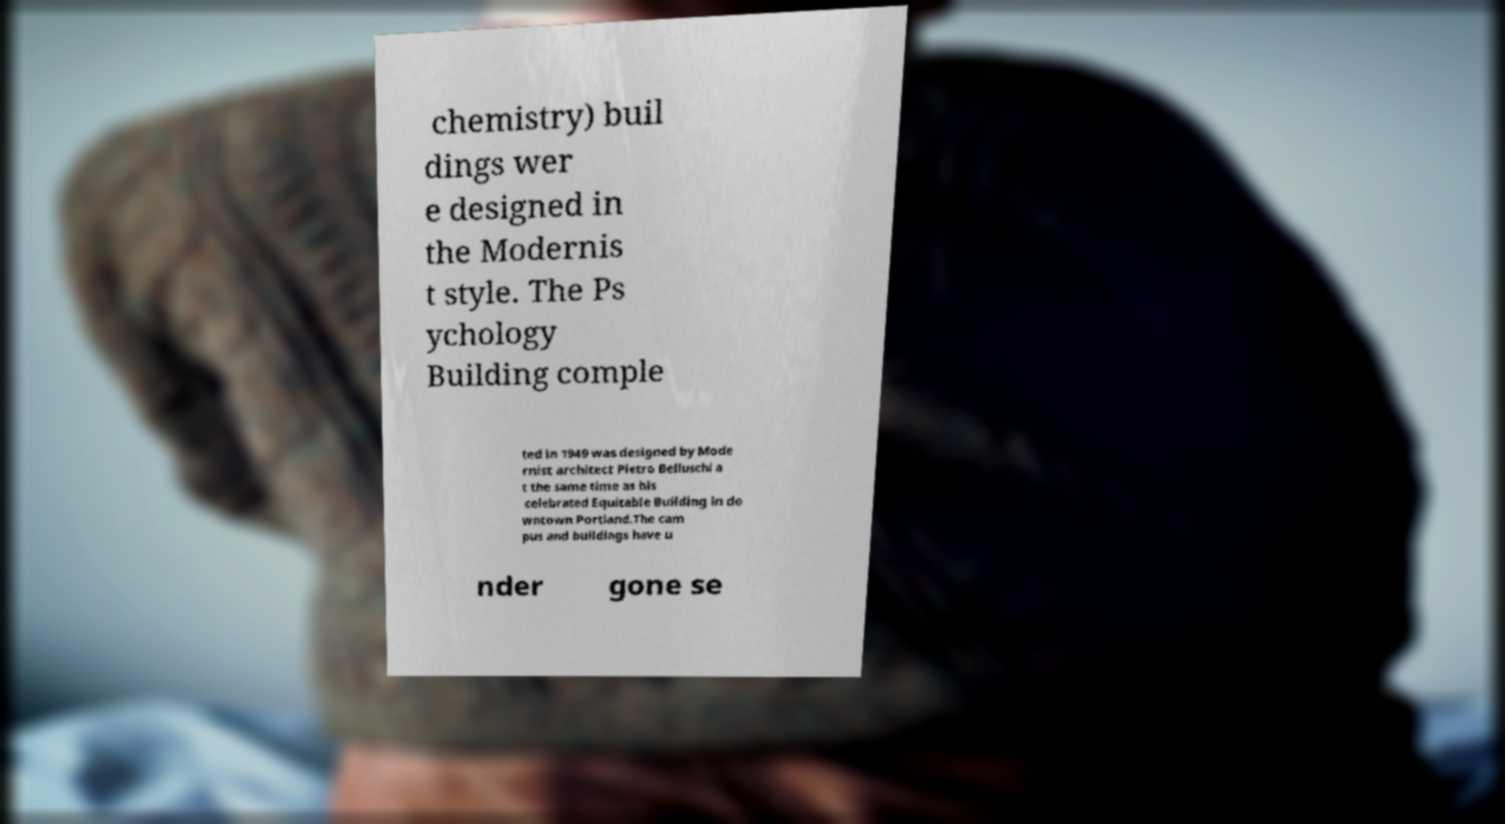Could you assist in decoding the text presented in this image and type it out clearly? chemistry) buil dings wer e designed in the Modernis t style. The Ps ychology Building comple ted in 1949 was designed by Mode rnist architect Pietro Belluschi a t the same time as his celebrated Equitable Building in do wntown Portland.The cam pus and buildings have u nder gone se 